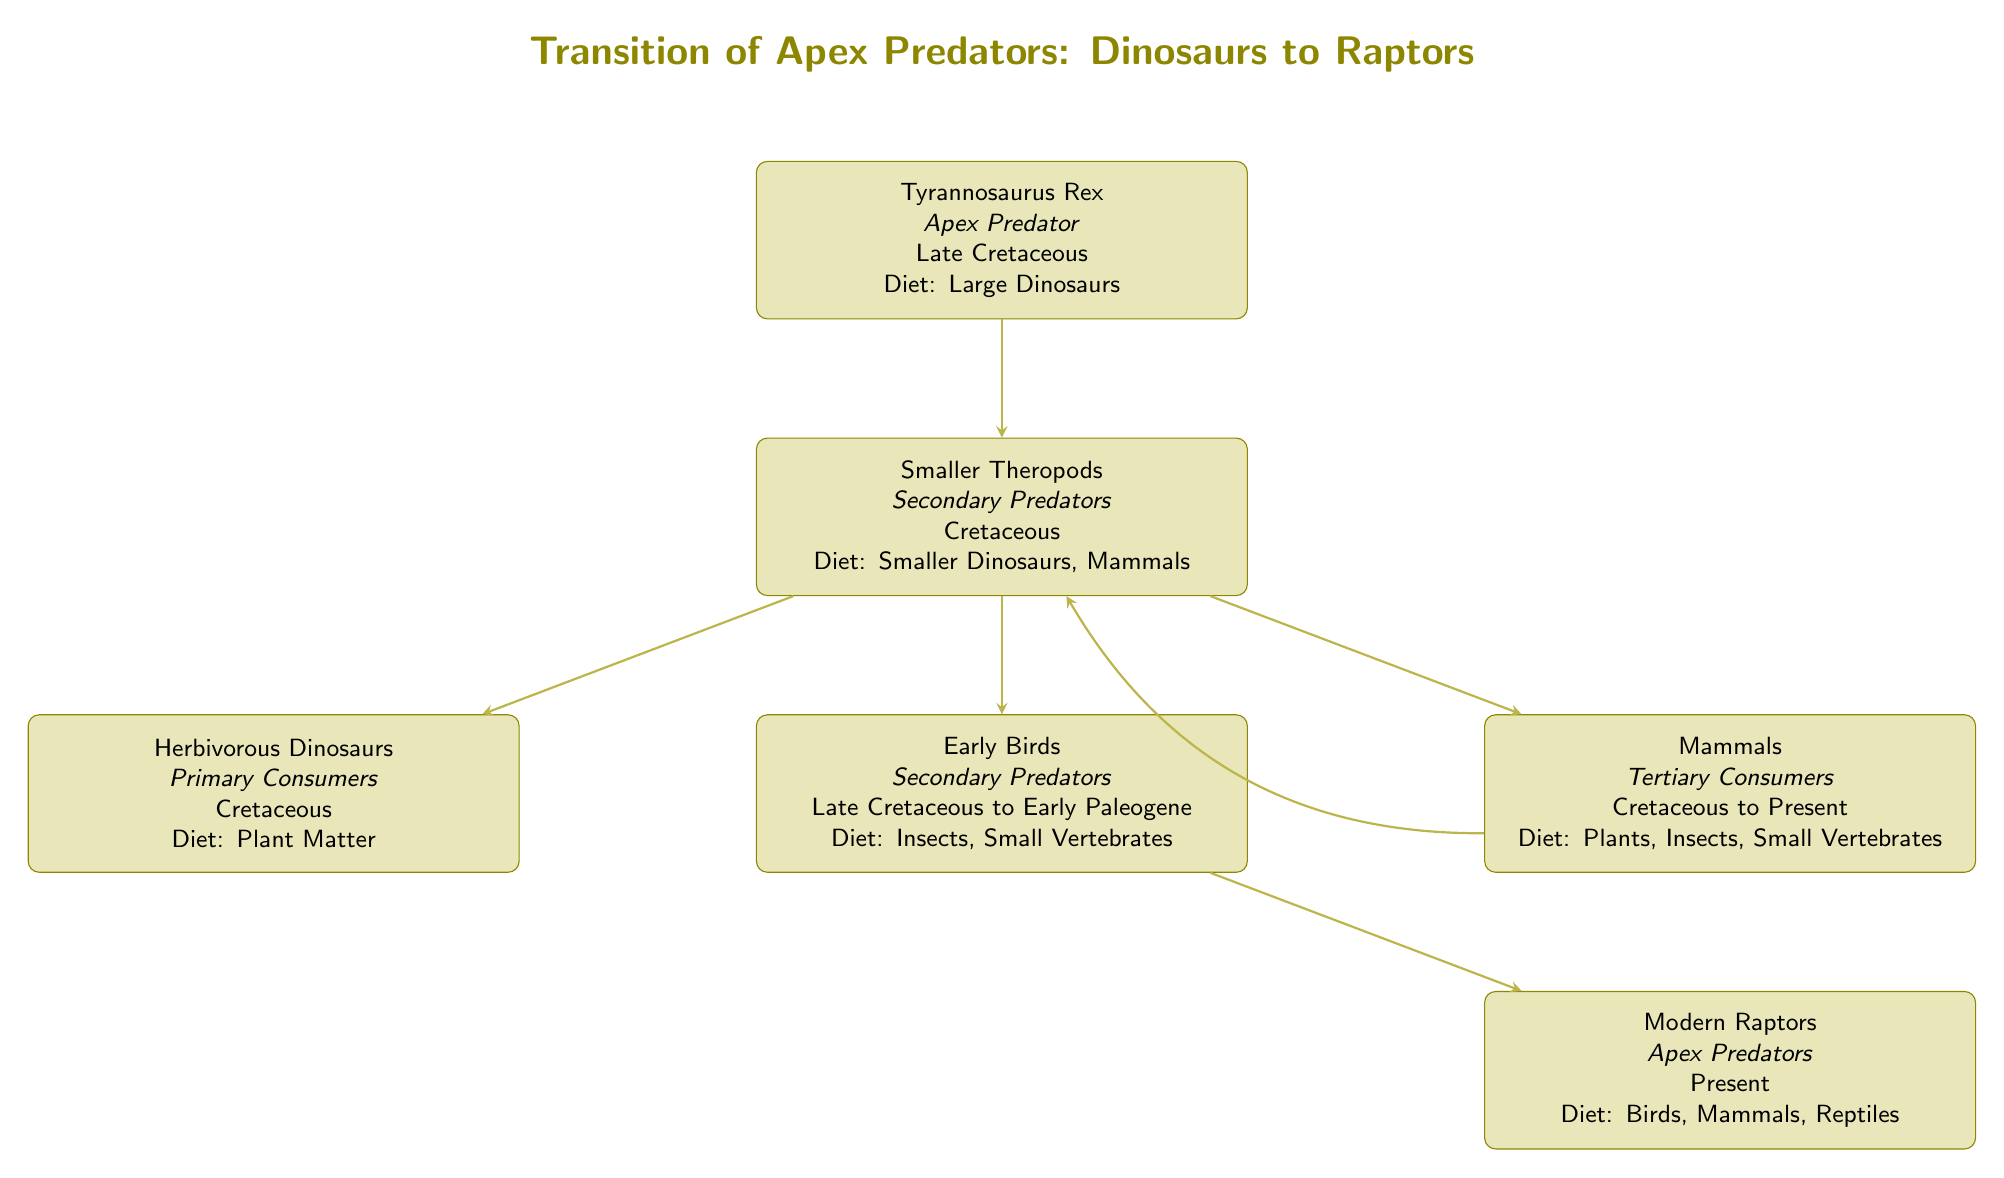What is the apex predator during the Late Cretaceous? The diagram identifies the Tyrannosaurus Rex as the apex predator in the Late Cretaceous period.
Answer: Tyrannosaurus Rex How many nodes represent apex predators in the diagram? The diagram features two nodes identified as apex predators: Tyrannosaurus Rex and Modern Raptors.
Answer: 2 What is the diet of modern raptors? The diagram specifies that modern raptors have a diet consisting of birds, mammals, and reptiles.
Answer: Birds, Mammals, Reptiles Which group of dinosaurs is considered primary consumers? The diagram labels herbivorous dinosaurs as primary consumers, indicating their dietary role within the food chain.
Answer: Herbivorous Dinosaurs What is the relationship between smaller theropods and mammals? The diagram shows a direct connection indicating that smaller theropods can interact with mammals; they have a predator-prey relationship as smaller theropods eat smaller dinosaurs, and mammals are another source.
Answer: Tertiary Consumers What is the diet of smaller theropods according to the diagram? The diagram states that smaller theropods primarily consume smaller dinosaurs and mammals as their diet.
Answer: Smaller Dinosaurs, Mammals Which two groups are classified as secondary predators? According to the diagram, smaller theropods and early birds are both identified as secondary predators.
Answer: Smaller Theropods, Early Birds In what time period did early birds exist? The diagram indicates that early birds existed from the Late Cretaceous to the Early Paleogene period.
Answer: Late Cretaceous to Early Paleogene What do herbivorous dinosaurs primarily consume? The diagram specifies that herbivorous dinosaurs primarily consume plant matter.
Answer: Plant Matter 